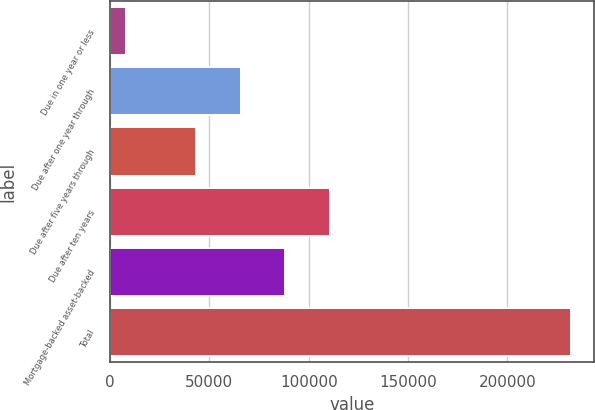<chart> <loc_0><loc_0><loc_500><loc_500><bar_chart><fcel>Due in one year or less<fcel>Due after one year through<fcel>Due after five years through<fcel>Due after ten years<fcel>Mortgage-backed asset-backed<fcel>Total<nl><fcel>7796<fcel>65752.5<fcel>43308<fcel>110642<fcel>88197<fcel>232241<nl></chart> 